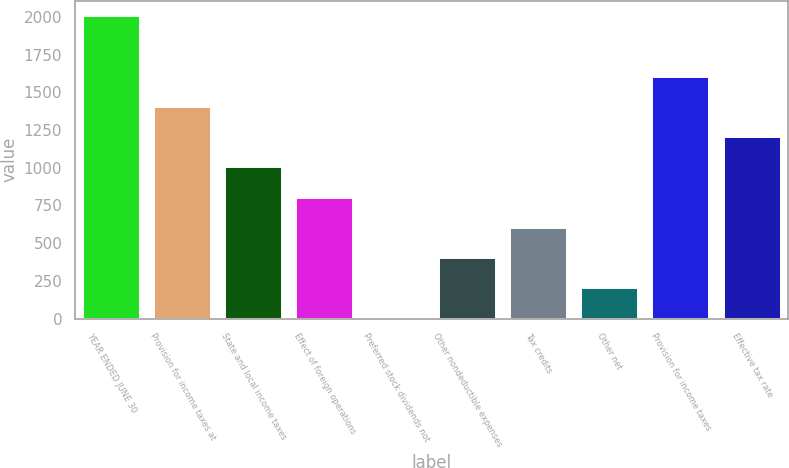Convert chart to OTSL. <chart><loc_0><loc_0><loc_500><loc_500><bar_chart><fcel>YEAR ENDED JUNE 30<fcel>Provision for income taxes at<fcel>State and local income taxes<fcel>Effect of foreign operations<fcel>Preferred stock dividends not<fcel>Other nondeductible expenses<fcel>Tax credits<fcel>Other net<fcel>Provision for income taxes<fcel>Effective tax rate<nl><fcel>2005<fcel>1403.59<fcel>1002.65<fcel>802.18<fcel>0.3<fcel>401.24<fcel>601.71<fcel>200.77<fcel>1604.06<fcel>1203.12<nl></chart> 